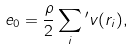Convert formula to latex. <formula><loc_0><loc_0><loc_500><loc_500>e _ { 0 } = \frac { \rho } { 2 } \sum _ { i } { ^ { \prime } } v ( r _ { i } ) ,</formula> 